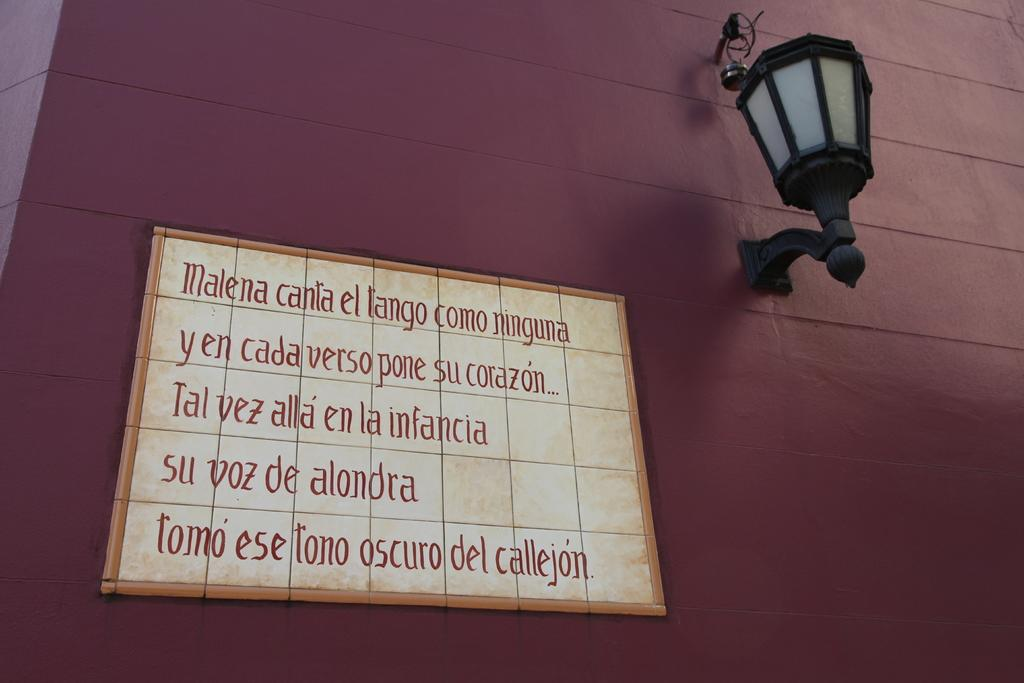What is attached to the wall in the image? There is a board attached to the wall in the image, and a lamp is attached to the wall on the right side. What can be seen on the board? There is text on the board. Can you see a pig made of silk in the image? There is no pig made of silk present in the image. How does the lamp pull the text on the board towards it? The lamp does not pull the text on the board towards it; the text is stationary on the board. 